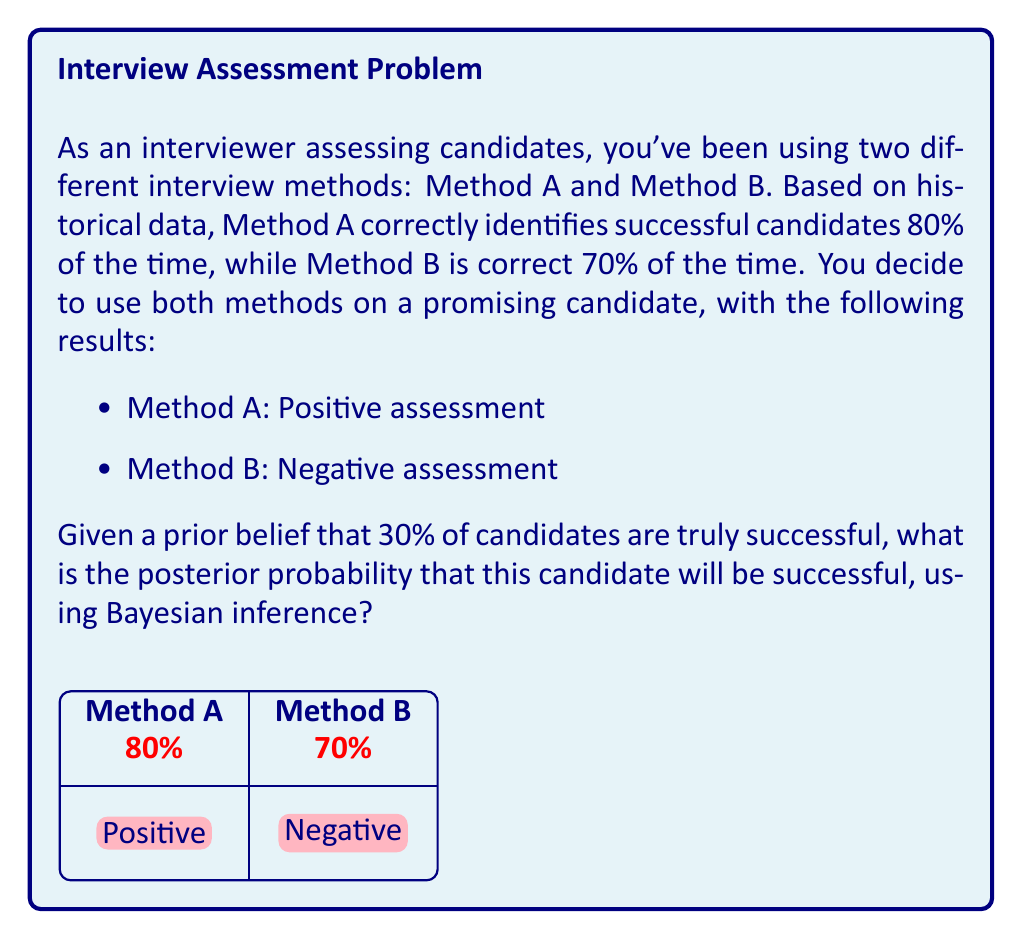What is the answer to this math problem? Let's approach this step-by-step using Bayes' theorem:

1) Define our events:
   S: Candidate is successful
   A: Method A gives a positive assessment
   B: Method B gives a negative assessment

2) We're given:
   P(S) = 0.30 (prior probability of success)
   P(A|S) = 0.80 (sensitivity of Method A)
   P(B|not S) = 0.70 (specificity of Method B)

3) We need to find P(S|A and B), which can be calculated using Bayes' theorem:

   $$P(S|A \text{ and } B) = \frac{P(A \text{ and } B|S) \cdot P(S)}{P(A \text{ and } B)}$$

4) Calculate P(A and B|S):
   P(A and B|S) = P(A|S) · P(B|S)
   P(B|S) = 1 - P(B|not S) = 1 - 0.70 = 0.30
   P(A and B|S) = 0.80 · 0.30 = 0.24

5) Calculate P(A and B):
   P(A and B) = P(A and B|S) · P(S) + P(A and B|not S) · P(not S)
   P(not S) = 1 - P(S) = 0.70
   P(A and B|not S) = P(A|not S) · P(B|not S) = (1 - 0.80) · 0.70 = 0.14
   P(A and B) = 0.24 · 0.30 + 0.14 · 0.70 = 0.072 + 0.098 = 0.17

6) Now we can apply Bayes' theorem:
   $$P(S|A \text{ and } B) = \frac{0.24 \cdot 0.30}{0.17} \approx 0.4235$$

Therefore, the posterior probability that the candidate will be successful is approximately 0.4235 or 42.35%.
Answer: 0.4235 